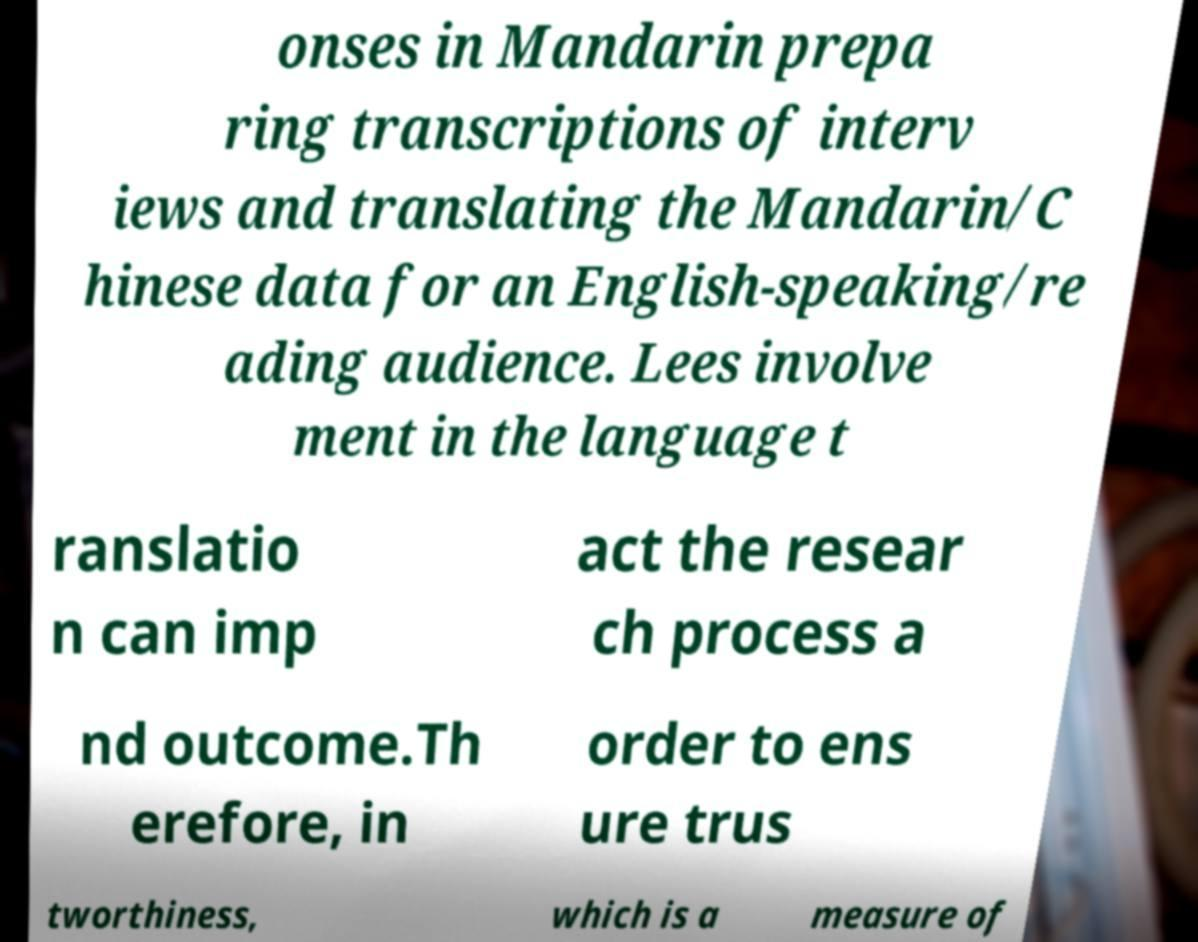I need the written content from this picture converted into text. Can you do that? onses in Mandarin prepa ring transcriptions of interv iews and translating the Mandarin/C hinese data for an English-speaking/re ading audience. Lees involve ment in the language t ranslatio n can imp act the resear ch process a nd outcome.Th erefore, in order to ens ure trus tworthiness, which is a measure of 